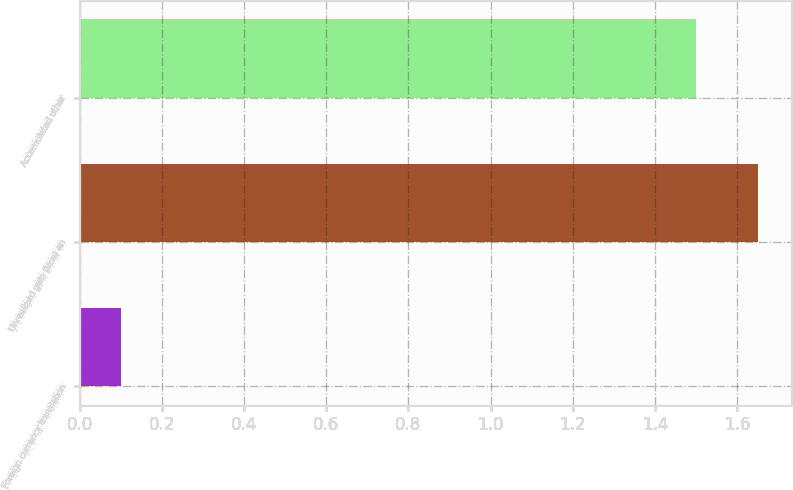<chart> <loc_0><loc_0><loc_500><loc_500><bar_chart><fcel>Foreign currency translation<fcel>Unrealized gain (loss) on<fcel>Accumulated other<nl><fcel>0.1<fcel>1.65<fcel>1.5<nl></chart> 